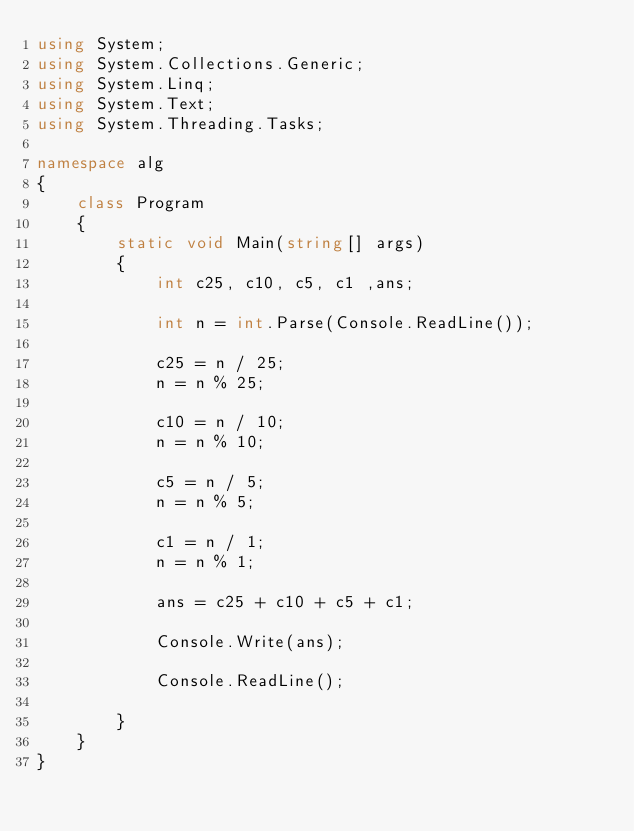Convert code to text. <code><loc_0><loc_0><loc_500><loc_500><_C#_>using System;
using System.Collections.Generic;
using System.Linq;
using System.Text;
using System.Threading.Tasks;

namespace alg
{
    class Program
    {
        static void Main(string[] args)
        {
            int c25, c10, c5, c1 ,ans;

            int n = int.Parse(Console.ReadLine());

            c25 = n / 25;
            n = n % 25;

            c10 = n / 10;
            n = n % 10;

            c5 = n / 5;
            n = n % 5;

            c1 = n / 1;
            n = n % 1;

            ans = c25 + c10 + c5 + c1;

            Console.Write(ans);

            Console.ReadLine();

        }
    }
}
</code> 